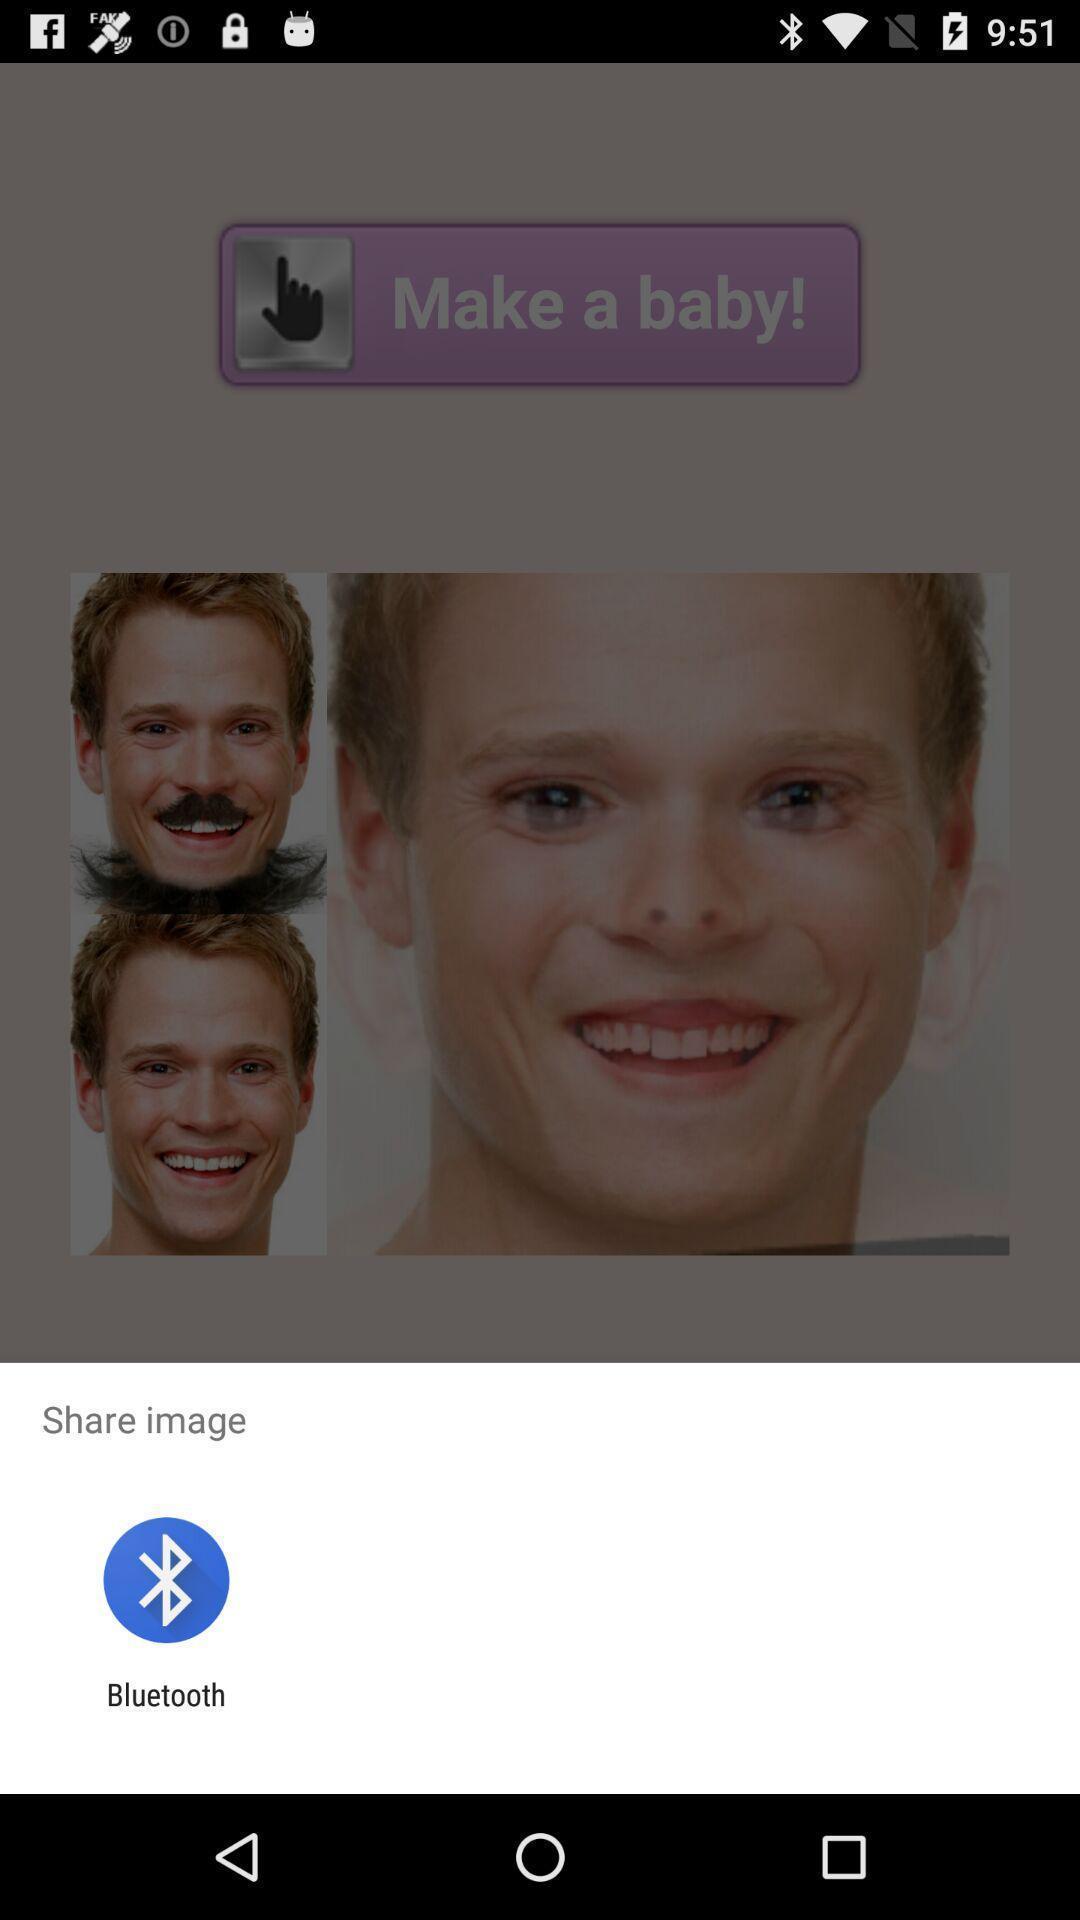Describe the key features of this screenshot. Pop up showing an application to share an image. 